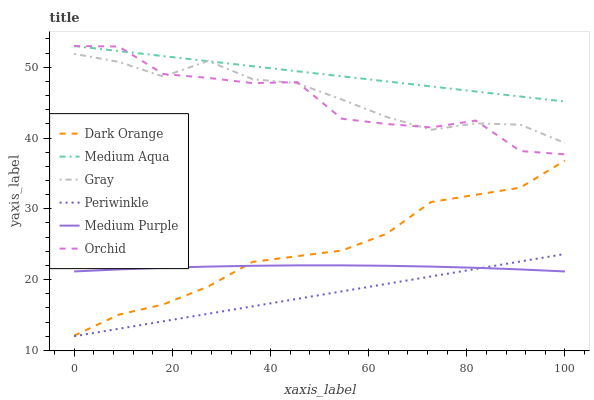Does Gray have the minimum area under the curve?
Answer yes or no. No. Does Gray have the maximum area under the curve?
Answer yes or no. No. Is Gray the smoothest?
Answer yes or no. No. Is Gray the roughest?
Answer yes or no. No. Does Gray have the lowest value?
Answer yes or no. No. Does Gray have the highest value?
Answer yes or no. No. Is Periwinkle less than Medium Aqua?
Answer yes or no. Yes. Is Gray greater than Periwinkle?
Answer yes or no. Yes. Does Periwinkle intersect Medium Aqua?
Answer yes or no. No. 